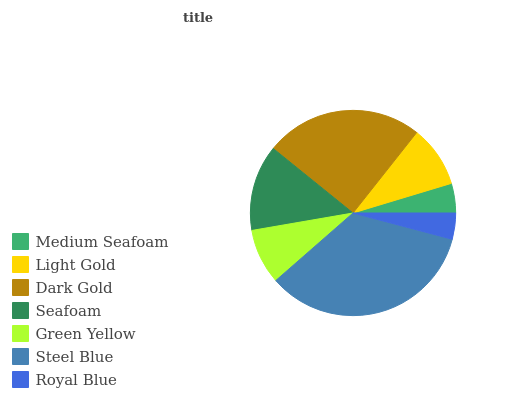Is Royal Blue the minimum?
Answer yes or no. Yes. Is Steel Blue the maximum?
Answer yes or no. Yes. Is Light Gold the minimum?
Answer yes or no. No. Is Light Gold the maximum?
Answer yes or no. No. Is Light Gold greater than Medium Seafoam?
Answer yes or no. Yes. Is Medium Seafoam less than Light Gold?
Answer yes or no. Yes. Is Medium Seafoam greater than Light Gold?
Answer yes or no. No. Is Light Gold less than Medium Seafoam?
Answer yes or no. No. Is Light Gold the high median?
Answer yes or no. Yes. Is Light Gold the low median?
Answer yes or no. Yes. Is Steel Blue the high median?
Answer yes or no. No. Is Seafoam the low median?
Answer yes or no. No. 